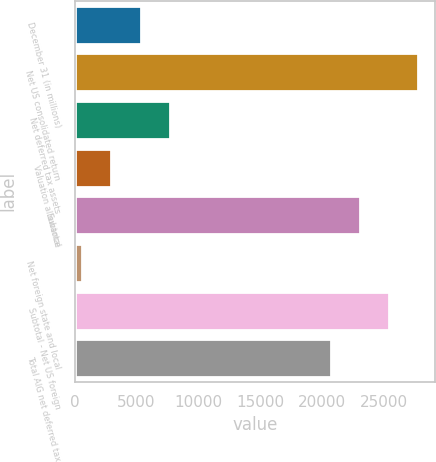Convert chart. <chart><loc_0><loc_0><loc_500><loc_500><bar_chart><fcel>December 31 (in millions)<fcel>Net US consolidated return<fcel>Net deferred tax assets<fcel>Valuation allowance<fcel>Subtotal<fcel>Net foreign state and local<fcel>Subtotal - Net US foreign<fcel>Total AIG net deferred tax<nl><fcel>5322.8<fcel>27766.2<fcel>7674.2<fcel>2971.4<fcel>23063.4<fcel>620<fcel>25414.8<fcel>20712<nl></chart> 